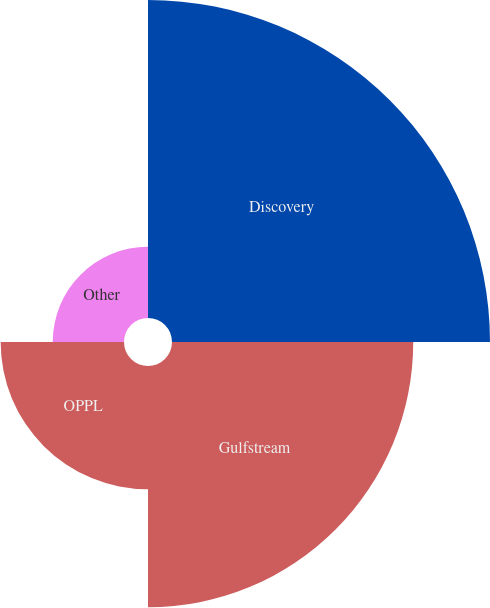Convert chart. <chart><loc_0><loc_0><loc_500><loc_500><pie_chart><fcel>Discovery<fcel>Gulfstream<fcel>OPPL<fcel>Other<nl><fcel>42.18%<fcel>32.0%<fcel>16.36%<fcel>9.45%<nl></chart> 